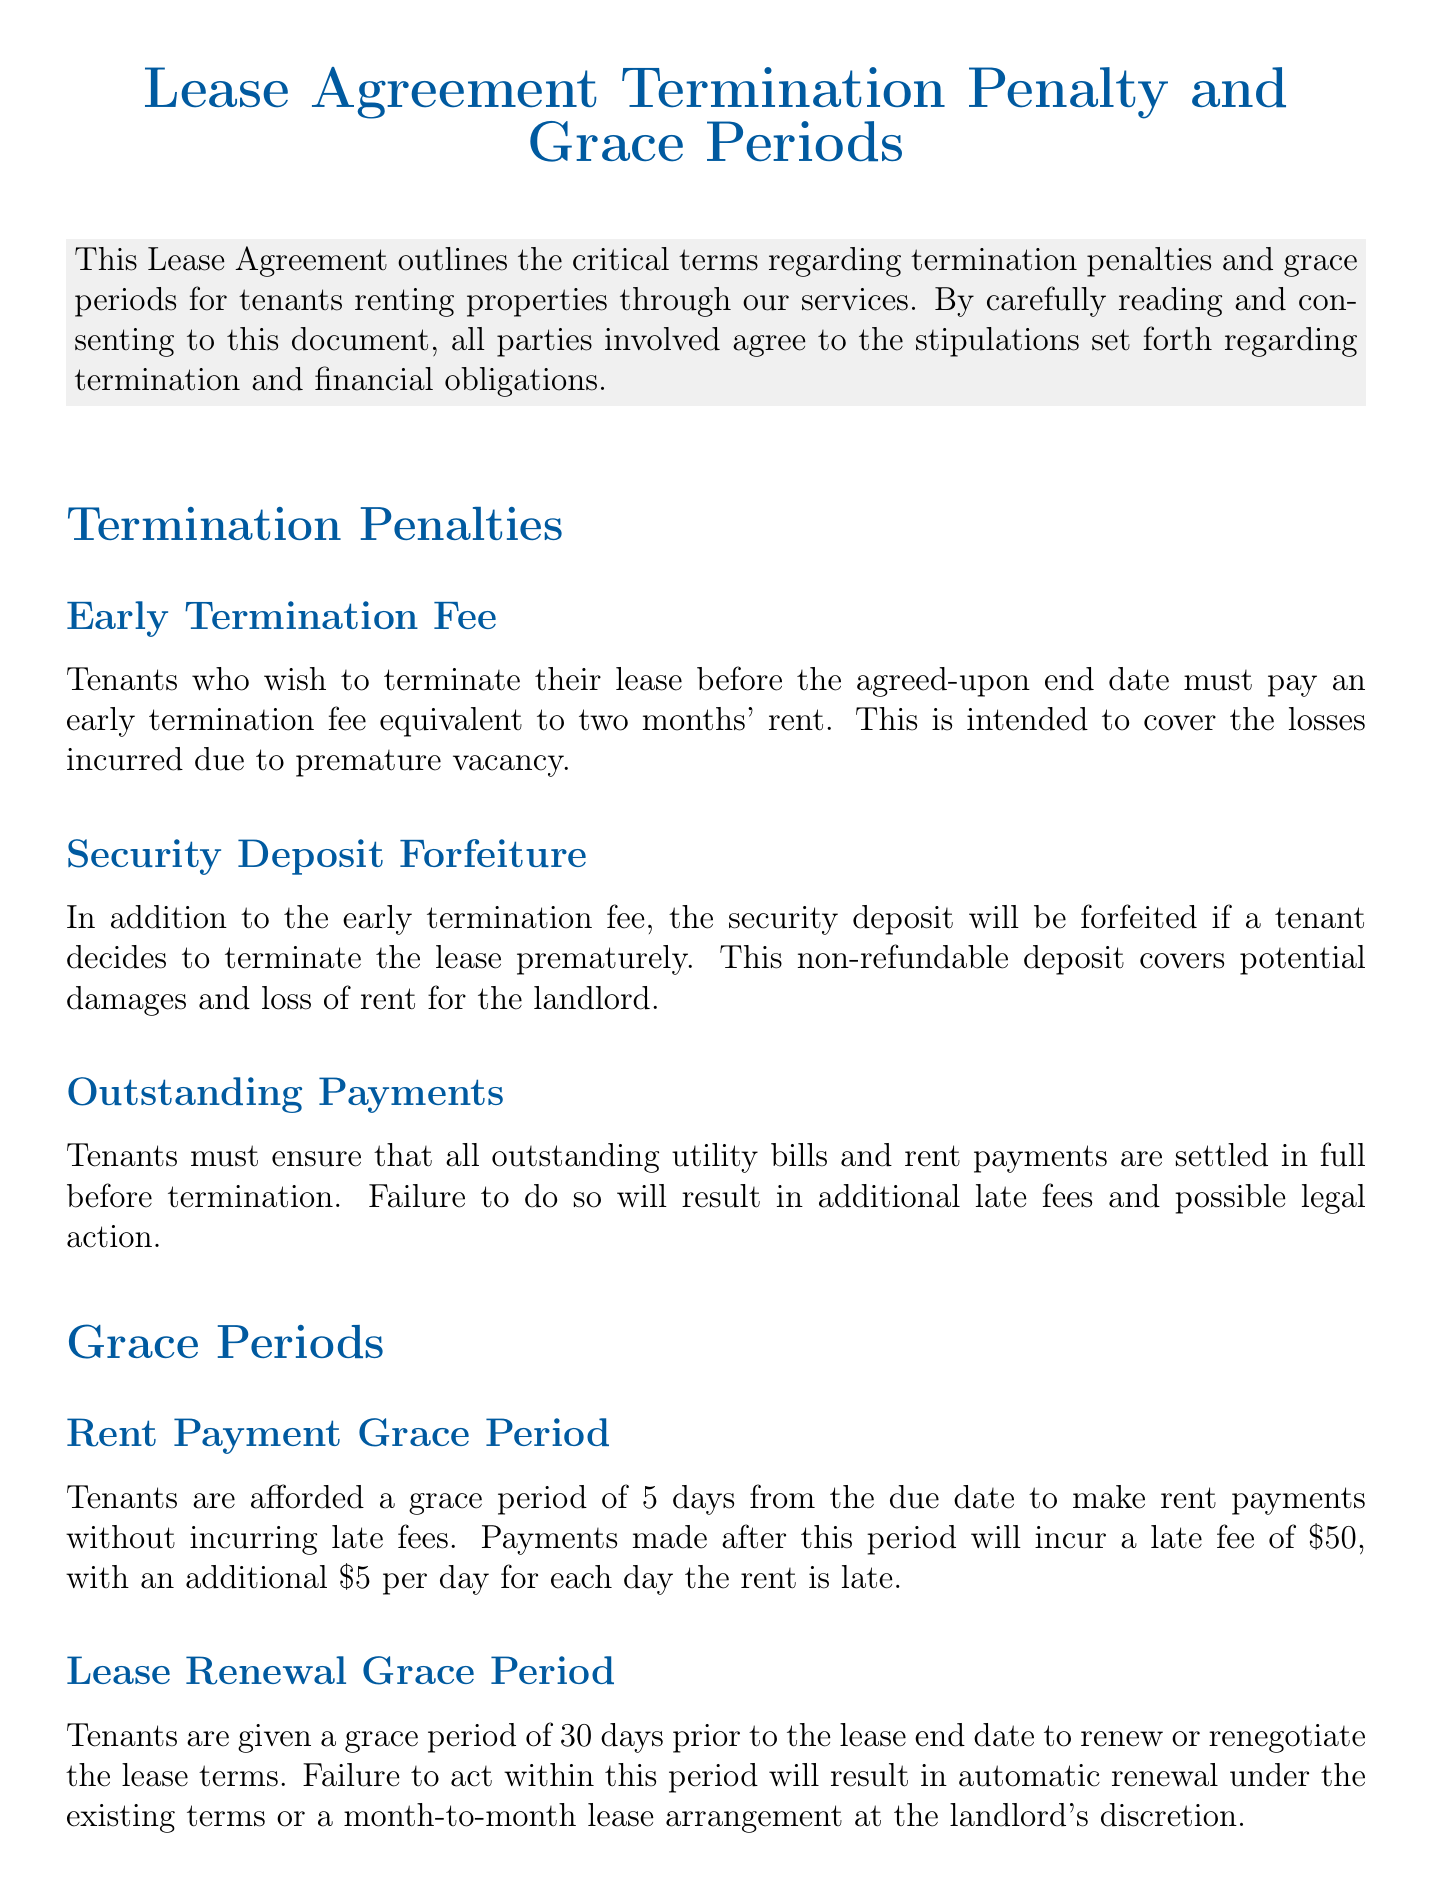What is the early termination fee? The document states that tenants must pay an early termination fee equivalent to two months' rent.
Answer: two months' rent What happens to the security deposit during early termination? It specifies that the security deposit will be forfeited if a tenant decides to terminate the lease prematurely.
Answer: forfeited How long is the rent payment grace period? The grace period for rent payments is specifically mentioned in the document.
Answer: 5 days What is the late fee for rent payments made after the grace period? It mentions a late fee applied to late rent payments after the grace period.
Answer: $50 What is the lease renewal grace period? The document describes a specific time frame for lease renewal discussions.
Answer: 30 days How long do tenants have to vacate the property after lease termination? The document details the timeframe tenants have for moving out without penalty.
Answer: 7 days What may happen if all outstanding payments are not settled before termination? It states the consequences of not paying outstanding bills before lease termination.
Answer: additional late fees and possible legal action What kind of lease arrangement occurs if a tenant fails to renew within the grace period? The document explains the result of inaction within the renewal grace period.
Answer: month-to-month lease arrangement What must tenants ensure before terminating the lease? The document specifies the obligations of tenants regarding payments before termination.
Answer: all outstanding utility bills and rent payments 